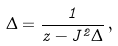<formula> <loc_0><loc_0><loc_500><loc_500>\Delta = \frac { 1 } { z - J ^ { 2 } \Delta } \, ,</formula> 